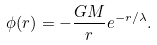Convert formula to latex. <formula><loc_0><loc_0><loc_500><loc_500>\phi ( r ) = - \frac { G M } { r } e ^ { - r / { \lambda } } .</formula> 